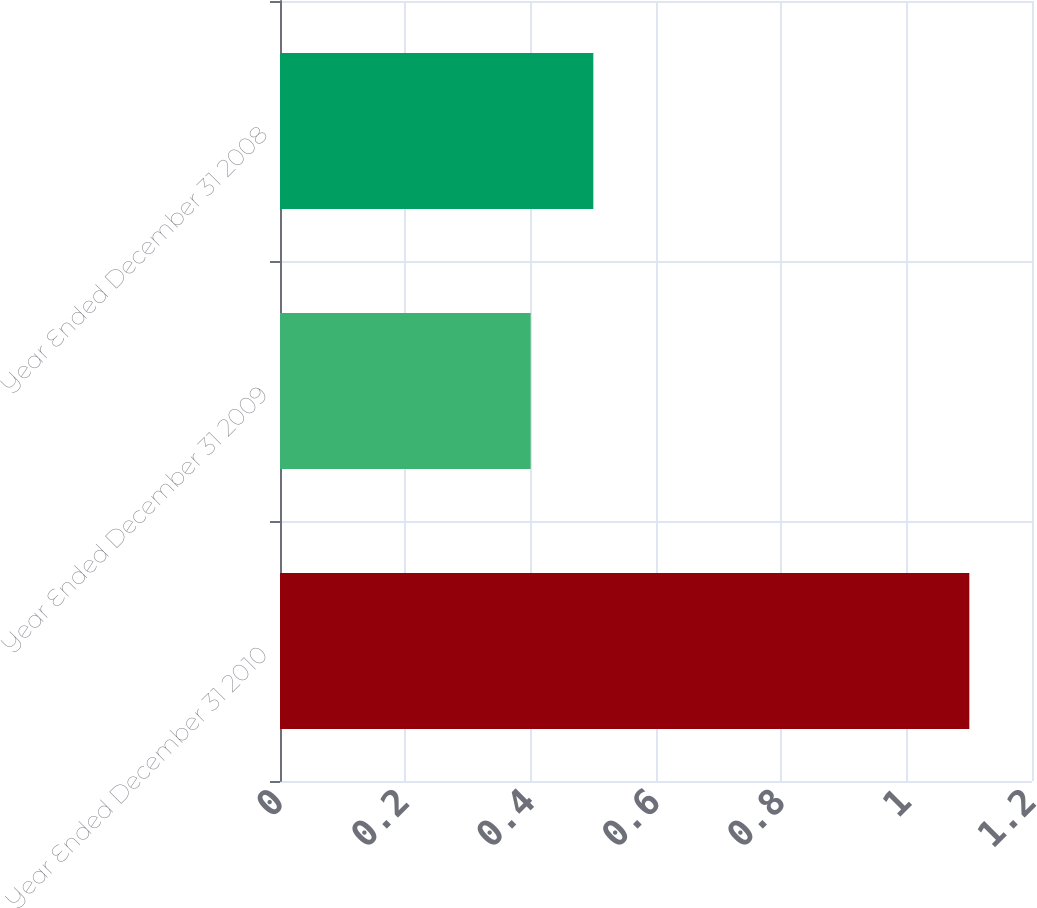<chart> <loc_0><loc_0><loc_500><loc_500><bar_chart><fcel>Year Ended December 31 2010<fcel>Year Ended December 31 2009<fcel>Year Ended December 31 2008<nl><fcel>1.1<fcel>0.4<fcel>0.5<nl></chart> 